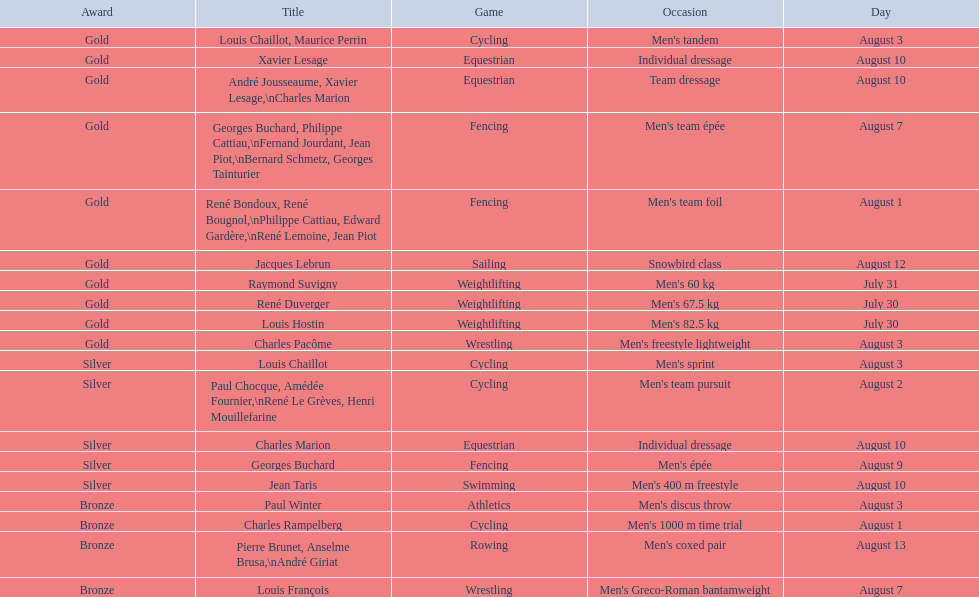What event is listed right before team dressage? Individual dressage. 